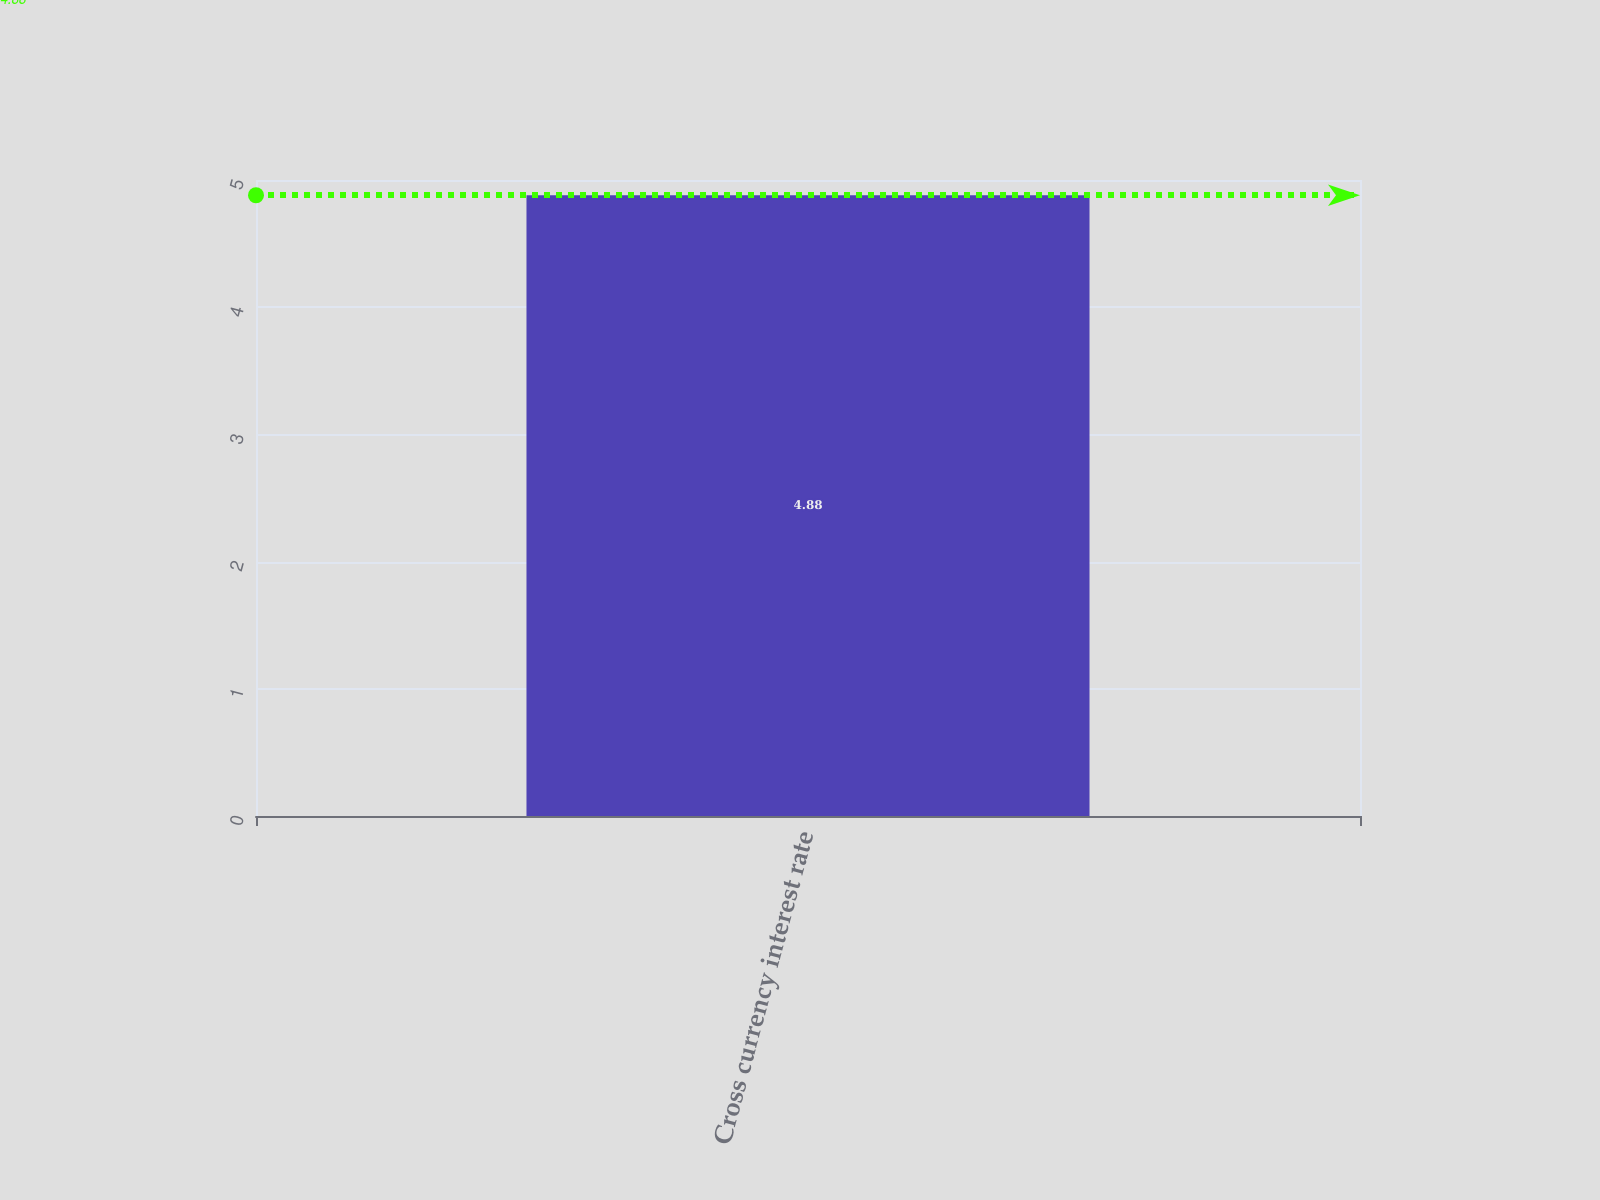<chart> <loc_0><loc_0><loc_500><loc_500><bar_chart><fcel>Cross currency interest rate<nl><fcel>4.88<nl></chart> 